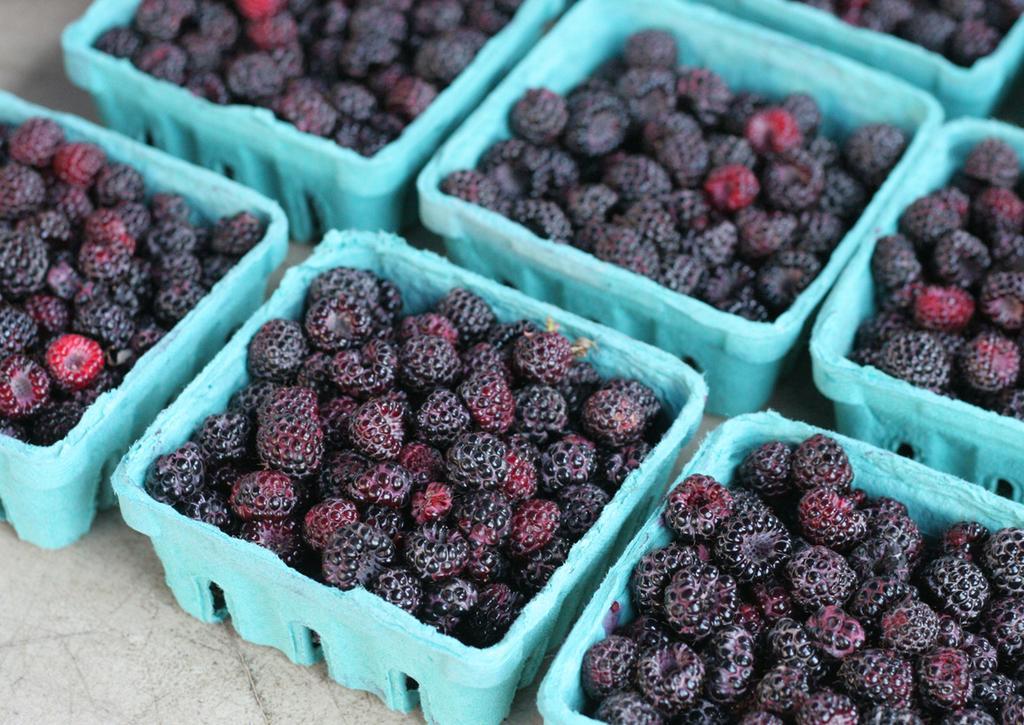Describe this image in one or two sentences. In this image, I can see the boxes with raspberries, which are kept on an object. 